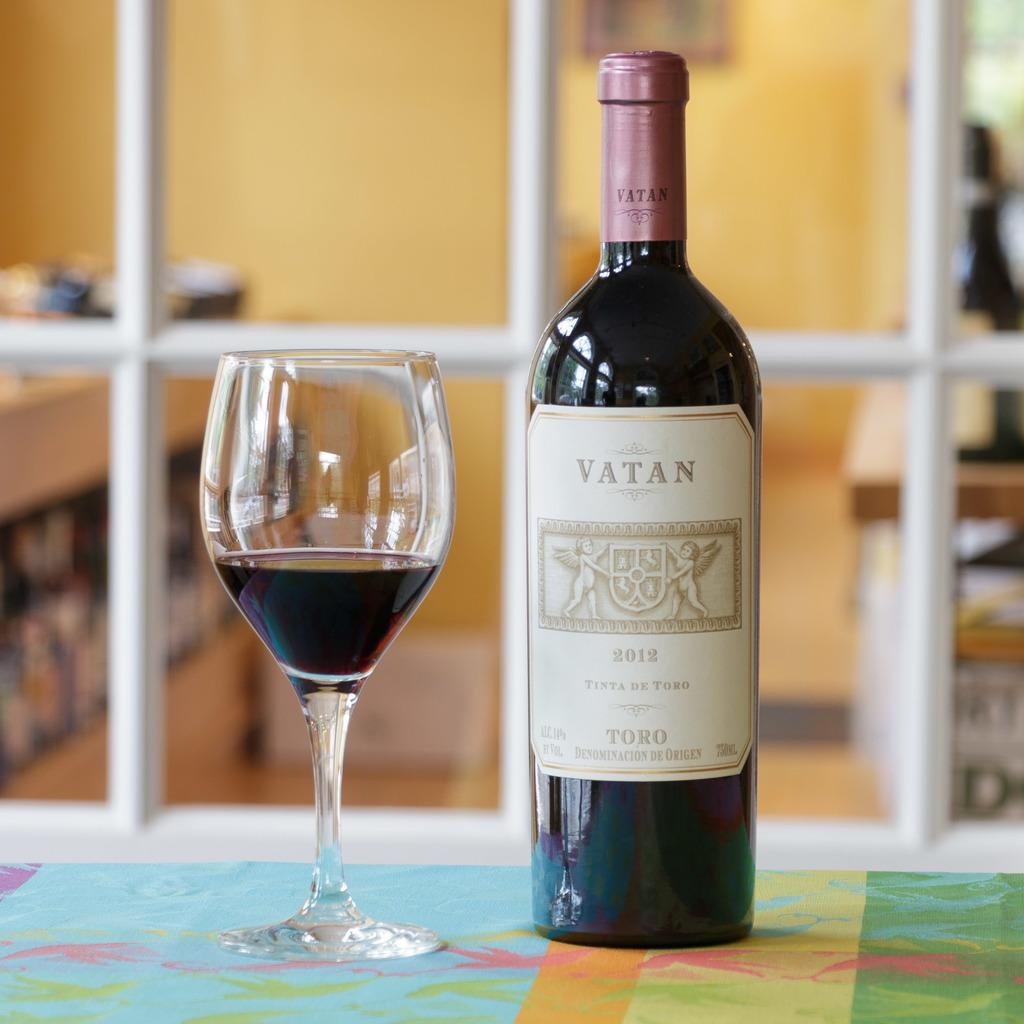<image>
Present a compact description of the photo's key features. Next to a wine glass containing a red wine is a bottle of Vatan 2012 Tinta De Toro. 